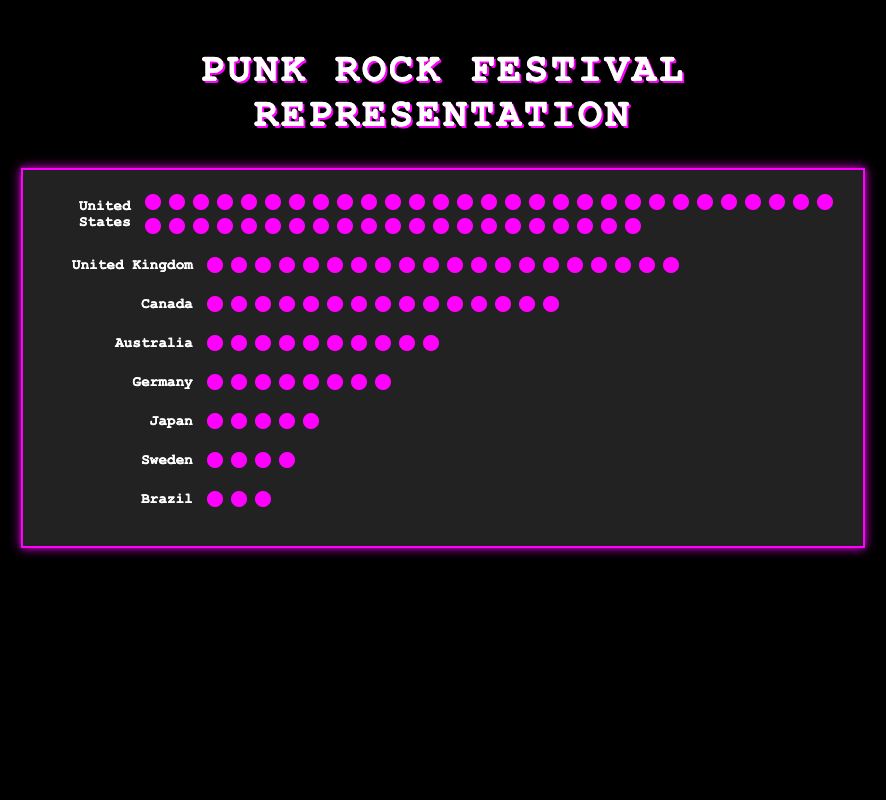Which country has the highest number of bands represented at the festival? From the visual data, locate the country with the most icons. The United States has 50 icons, indicating it has the highest representation.
Answer: United States How many more bands does the United Kingdom have compared to Sweden? Count the icons for the United Kingdom (20) and for Sweden (4). Subtract the number of Swedish icons from the number of UK icons: 20 - 4 = 16.
Answer: 16 What is the total number of bands from Germany and Japan combined? Count the icons for Germany (8) and for Japan (5). Add the two numbers together: 8 + 5 = 13.
Answer: 13 Which countries have fewer than 10 bands represented? Identify countries with less than 10 icons. The countries are Germany (8), Japan (5), Sweden (4), and Brazil (3).
Answer: Germany, Japan, Sweden, Brazil What percentage of the total bands come from Canada? First, find the total number of bands by summing all the icons: 50 + 20 + 15 + 10 + 8 + 5 + 4 + 3 = 115. Canada has 15 bands. Calculate the percentage by (15 / 115) * 100 = 13.04%.
Answer: 13.04% How many countries have more than 10 bands represented? Identify and count the countries with more than 10 icons: United States (50), United Kingdom (20), and Canada (15). Count the number of such countries, which is 3.
Answer: 3 Which country has the smallest representation at the festival? Find the country with the least number of icons. Brazil has the smallest representation with 3 bands.
Answer: Brazil How many bands come from countries located in Europe? Identify the European countries and sum their number of icons: United Kingdom (20), Germany (8), and Sweden (4). Add the numbers: 20 + 8 + 4 = 32.
Answer: 32 What is the average number of bands per country? Sum the total number of bands (115) and divide by the number of countries (8). The average number is 115 / 8 = 14.38.
Answer: 14.38 Are there more bands from Australia or Japan? Count the icons for Australia (10) and Japan (5). Compare the numbers. Australia has more bands than Japan.
Answer: Australia 